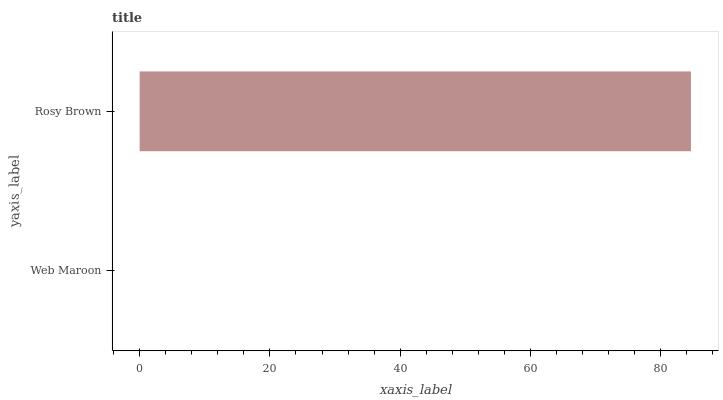Is Web Maroon the minimum?
Answer yes or no. Yes. Is Rosy Brown the maximum?
Answer yes or no. Yes. Is Rosy Brown the minimum?
Answer yes or no. No. Is Rosy Brown greater than Web Maroon?
Answer yes or no. Yes. Is Web Maroon less than Rosy Brown?
Answer yes or no. Yes. Is Web Maroon greater than Rosy Brown?
Answer yes or no. No. Is Rosy Brown less than Web Maroon?
Answer yes or no. No. Is Rosy Brown the high median?
Answer yes or no. Yes. Is Web Maroon the low median?
Answer yes or no. Yes. Is Web Maroon the high median?
Answer yes or no. No. Is Rosy Brown the low median?
Answer yes or no. No. 